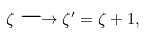<formula> <loc_0><loc_0><loc_500><loc_500>\zeta \longrightarrow \zeta ^ { \prime } = \zeta + 1 ,</formula> 